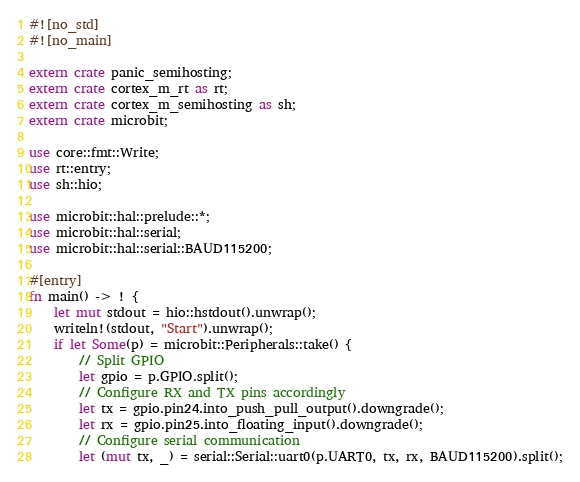Convert code to text. <code><loc_0><loc_0><loc_500><loc_500><_Rust_>#![no_std]
#![no_main]

extern crate panic_semihosting;
extern crate cortex_m_rt as rt;
extern crate cortex_m_semihosting as sh;
extern crate microbit;

use core::fmt::Write;
use rt::entry;
use sh::hio;

use microbit::hal::prelude::*;
use microbit::hal::serial;
use microbit::hal::serial::BAUD115200;

#[entry]
fn main() -> ! {
    let mut stdout = hio::hstdout().unwrap();
    writeln!(stdout, "Start").unwrap();
    if let Some(p) = microbit::Peripherals::take() {
        // Split GPIO
        let gpio = p.GPIO.split();
        // Configure RX and TX pins accordingly
        let tx = gpio.pin24.into_push_pull_output().downgrade();
        let rx = gpio.pin25.into_floating_input().downgrade();
        // Configure serial communication
        let (mut tx, _) = serial::Serial::uart0(p.UART0, tx, rx, BAUD115200).split();</code> 